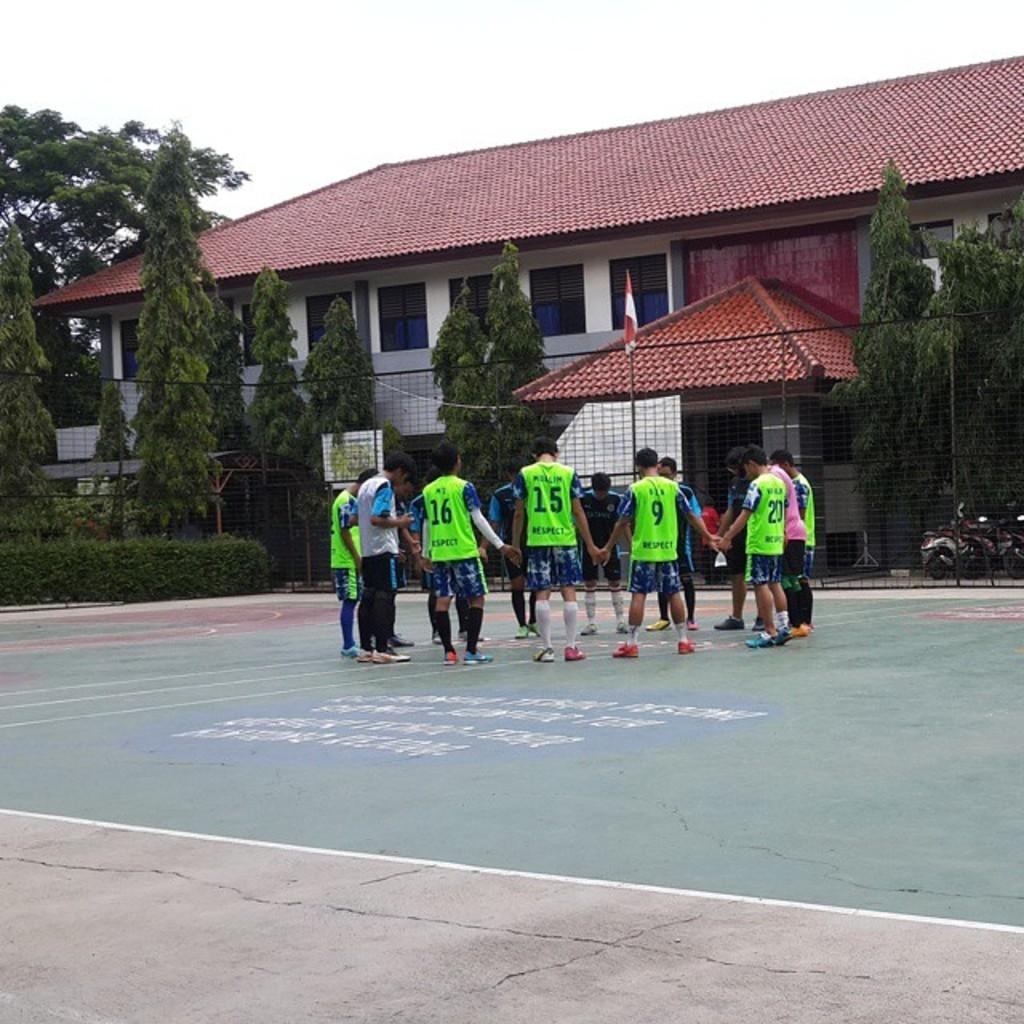How many people are in the image? There is a group of people standing together in the image. What is the surface on which the people are standing? The people are standing in the image are on the ground. What type of natural elements can be seen in the image? There are trees visible in the image. Can any man-made structures be identified in the image? Yes, there is at least one building present in the image. What is the degree of the drain in the image? There is no drain present in the image, so it is not possible to determine its degree. 